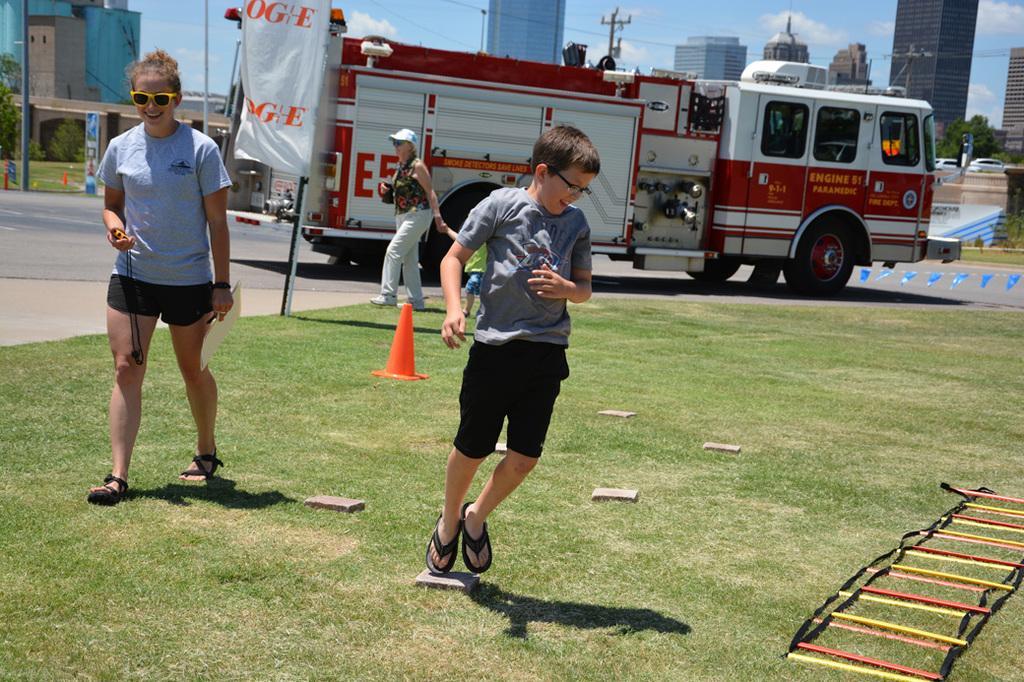Please provide a concise description of this image. This picture is clicked outside. In the foreground we can see there are some objects lying on the ground and we can see a kid wearing t-shirt and seems to be running on the ground. On the left we can see the two persons walking on the ground and we can see the green grass and flags hanging on the rope and we can see a vehicle running on the road and we can see the text on the banner. In the background we can see the sky, cables, poles, buildings, trees, vehicles and many other objects. 